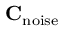<formula> <loc_0><loc_0><loc_500><loc_500>C _ { n o i s e }</formula> 